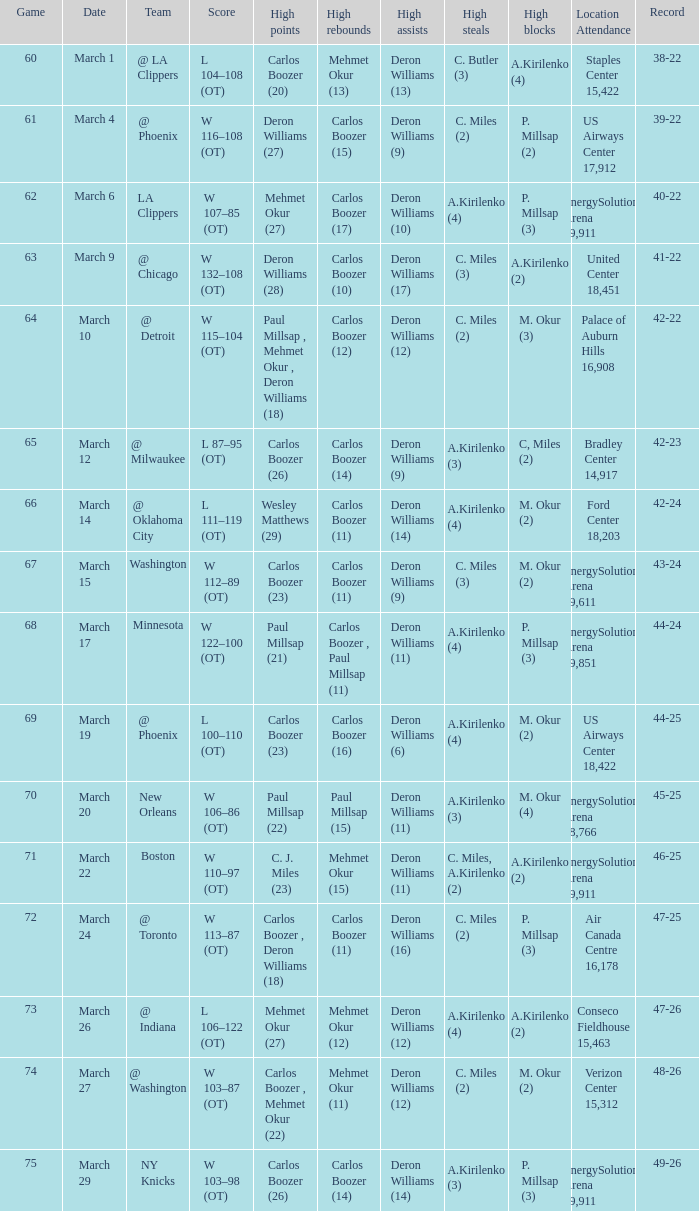What was the record at the game where Deron Williams (6) did the high assists? 44-25. 